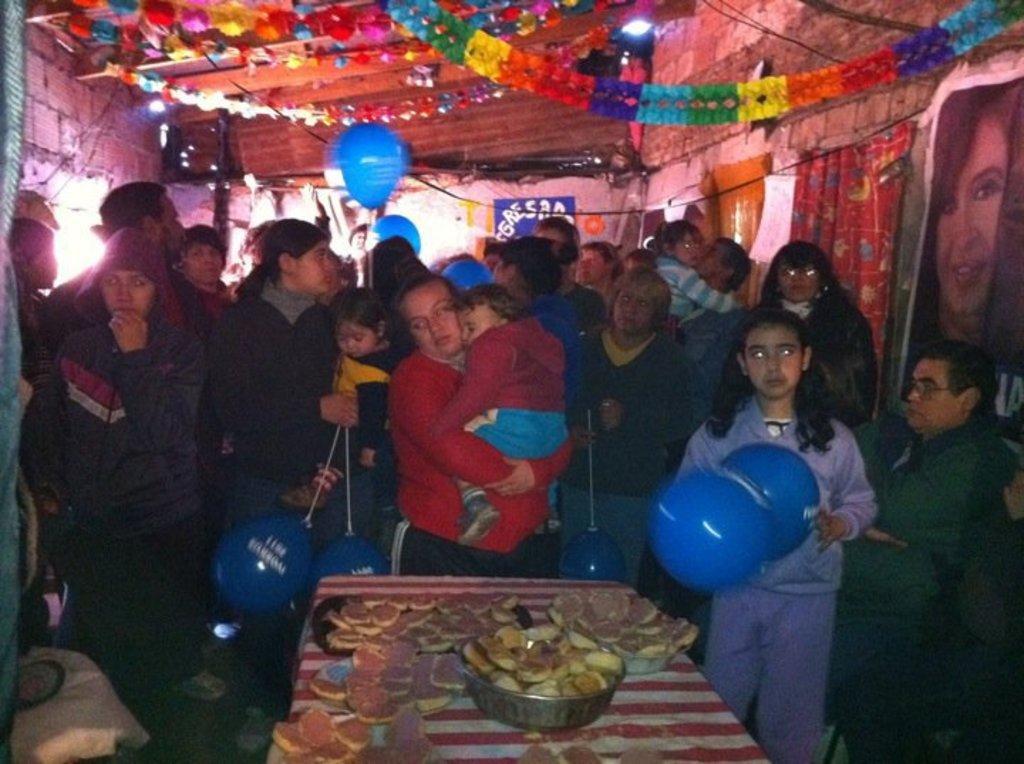Describe this image in one or two sentences. This image is taken in a room. In this image there are a few people standing and few are holding balloons in their hands, in front of them there is a table with some stuff on it. At the top of the image there is a ceiling with some decoration. On the right side of the image there are few posters are attached to a wall. 